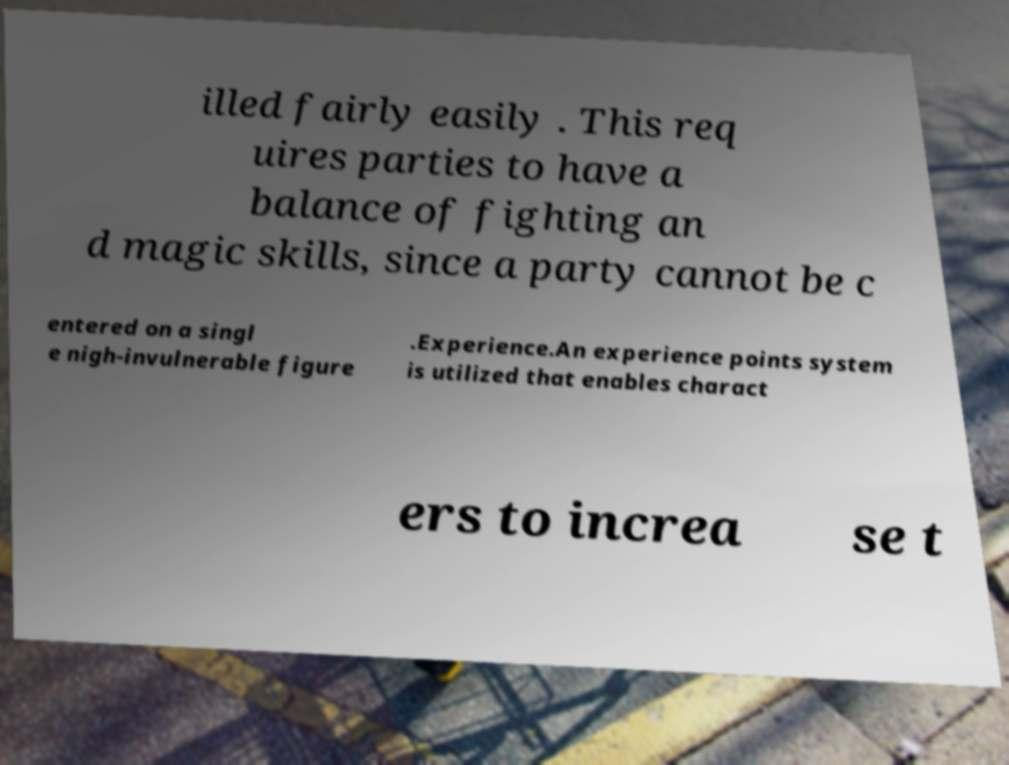Can you accurately transcribe the text from the provided image for me? illed fairly easily . This req uires parties to have a balance of fighting an d magic skills, since a party cannot be c entered on a singl e nigh-invulnerable figure .Experience.An experience points system is utilized that enables charact ers to increa se t 